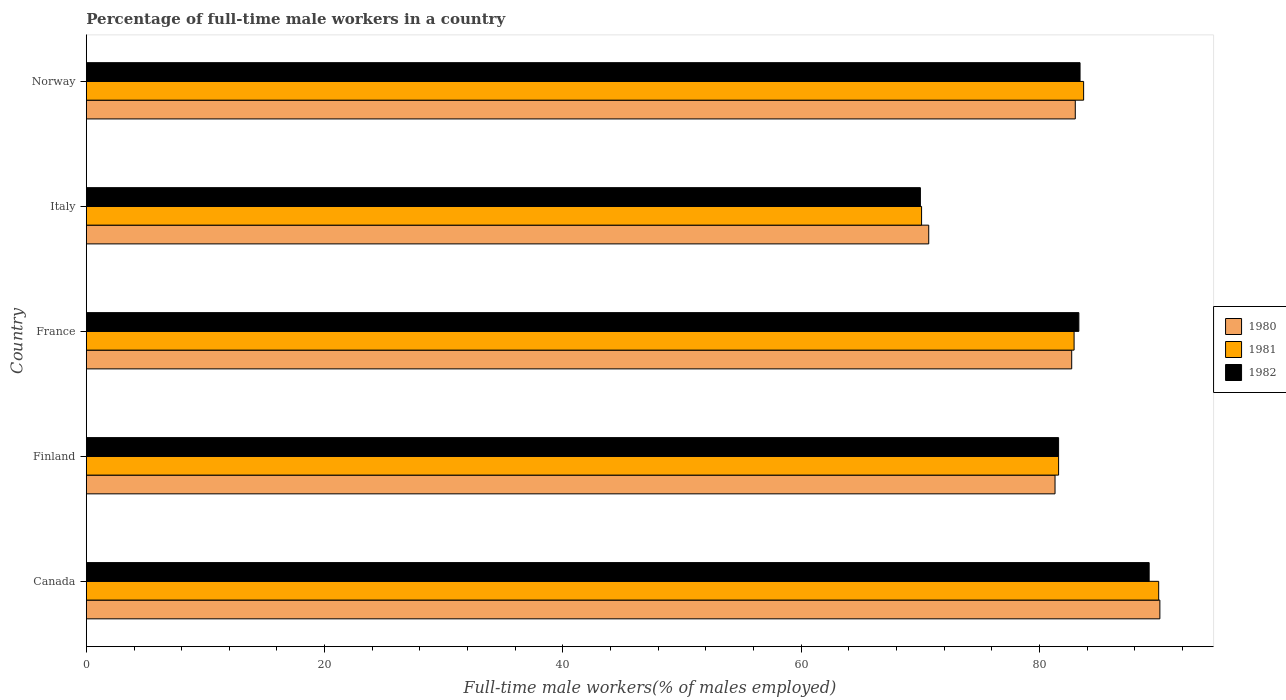How many different coloured bars are there?
Provide a succinct answer. 3. Are the number of bars per tick equal to the number of legend labels?
Provide a succinct answer. Yes. How many bars are there on the 4th tick from the top?
Give a very brief answer. 3. How many bars are there on the 4th tick from the bottom?
Give a very brief answer. 3. What is the label of the 1st group of bars from the top?
Your answer should be very brief. Norway. What is the percentage of full-time male workers in 1980 in Finland?
Provide a succinct answer. 81.3. Across all countries, what is the maximum percentage of full-time male workers in 1981?
Give a very brief answer. 90. What is the total percentage of full-time male workers in 1982 in the graph?
Your response must be concise. 407.5. What is the difference between the percentage of full-time male workers in 1982 in France and that in Norway?
Offer a very short reply. -0.1. What is the difference between the percentage of full-time male workers in 1982 in Canada and the percentage of full-time male workers in 1980 in Norway?
Your answer should be very brief. 6.2. What is the average percentage of full-time male workers in 1980 per country?
Your answer should be compact. 81.56. What is the difference between the percentage of full-time male workers in 1980 and percentage of full-time male workers in 1982 in Italy?
Keep it short and to the point. 0.7. In how many countries, is the percentage of full-time male workers in 1981 greater than 64 %?
Offer a terse response. 5. What is the ratio of the percentage of full-time male workers in 1981 in Canada to that in Finland?
Make the answer very short. 1.1. Is the percentage of full-time male workers in 1981 in Finland less than that in Norway?
Keep it short and to the point. Yes. Is the difference between the percentage of full-time male workers in 1980 in Canada and Norway greater than the difference between the percentage of full-time male workers in 1982 in Canada and Norway?
Make the answer very short. Yes. What is the difference between the highest and the second highest percentage of full-time male workers in 1982?
Offer a terse response. 5.8. What is the difference between the highest and the lowest percentage of full-time male workers in 1981?
Offer a terse response. 19.9. Is the sum of the percentage of full-time male workers in 1982 in Finland and Italy greater than the maximum percentage of full-time male workers in 1981 across all countries?
Ensure brevity in your answer.  Yes. Is it the case that in every country, the sum of the percentage of full-time male workers in 1981 and percentage of full-time male workers in 1982 is greater than the percentage of full-time male workers in 1980?
Keep it short and to the point. Yes. How many countries are there in the graph?
Offer a very short reply. 5. What is the difference between two consecutive major ticks on the X-axis?
Give a very brief answer. 20. Are the values on the major ticks of X-axis written in scientific E-notation?
Provide a succinct answer. No. Does the graph contain any zero values?
Provide a succinct answer. No. What is the title of the graph?
Ensure brevity in your answer.  Percentage of full-time male workers in a country. Does "2009" appear as one of the legend labels in the graph?
Make the answer very short. No. What is the label or title of the X-axis?
Your answer should be compact. Full-time male workers(% of males employed). What is the label or title of the Y-axis?
Provide a short and direct response. Country. What is the Full-time male workers(% of males employed) of 1980 in Canada?
Provide a short and direct response. 90.1. What is the Full-time male workers(% of males employed) in 1982 in Canada?
Provide a short and direct response. 89.2. What is the Full-time male workers(% of males employed) of 1980 in Finland?
Offer a terse response. 81.3. What is the Full-time male workers(% of males employed) of 1981 in Finland?
Give a very brief answer. 81.6. What is the Full-time male workers(% of males employed) of 1982 in Finland?
Provide a short and direct response. 81.6. What is the Full-time male workers(% of males employed) of 1980 in France?
Ensure brevity in your answer.  82.7. What is the Full-time male workers(% of males employed) of 1981 in France?
Offer a terse response. 82.9. What is the Full-time male workers(% of males employed) in 1982 in France?
Your response must be concise. 83.3. What is the Full-time male workers(% of males employed) of 1980 in Italy?
Make the answer very short. 70.7. What is the Full-time male workers(% of males employed) in 1981 in Italy?
Offer a terse response. 70.1. What is the Full-time male workers(% of males employed) in 1982 in Italy?
Make the answer very short. 70. What is the Full-time male workers(% of males employed) of 1980 in Norway?
Keep it short and to the point. 83. What is the Full-time male workers(% of males employed) in 1981 in Norway?
Offer a terse response. 83.7. What is the Full-time male workers(% of males employed) of 1982 in Norway?
Your answer should be very brief. 83.4. Across all countries, what is the maximum Full-time male workers(% of males employed) in 1980?
Offer a terse response. 90.1. Across all countries, what is the maximum Full-time male workers(% of males employed) of 1981?
Ensure brevity in your answer.  90. Across all countries, what is the maximum Full-time male workers(% of males employed) in 1982?
Provide a succinct answer. 89.2. Across all countries, what is the minimum Full-time male workers(% of males employed) of 1980?
Offer a terse response. 70.7. Across all countries, what is the minimum Full-time male workers(% of males employed) in 1981?
Provide a short and direct response. 70.1. What is the total Full-time male workers(% of males employed) in 1980 in the graph?
Offer a terse response. 407.8. What is the total Full-time male workers(% of males employed) in 1981 in the graph?
Your response must be concise. 408.3. What is the total Full-time male workers(% of males employed) in 1982 in the graph?
Your answer should be very brief. 407.5. What is the difference between the Full-time male workers(% of males employed) in 1981 in Canada and that in Finland?
Make the answer very short. 8.4. What is the difference between the Full-time male workers(% of males employed) in 1982 in Canada and that in Finland?
Your answer should be compact. 7.6. What is the difference between the Full-time male workers(% of males employed) in 1981 in Canada and that in France?
Provide a short and direct response. 7.1. What is the difference between the Full-time male workers(% of males employed) of 1980 in Canada and that in Italy?
Offer a terse response. 19.4. What is the difference between the Full-time male workers(% of males employed) in 1982 in Canada and that in Italy?
Offer a very short reply. 19.2. What is the difference between the Full-time male workers(% of males employed) of 1980 in Canada and that in Norway?
Offer a very short reply. 7.1. What is the difference between the Full-time male workers(% of males employed) of 1981 in Canada and that in Norway?
Offer a terse response. 6.3. What is the difference between the Full-time male workers(% of males employed) of 1981 in Finland and that in France?
Keep it short and to the point. -1.3. What is the difference between the Full-time male workers(% of males employed) of 1980 in Finland and that in Italy?
Your response must be concise. 10.6. What is the difference between the Full-time male workers(% of males employed) of 1981 in Finland and that in Italy?
Keep it short and to the point. 11.5. What is the difference between the Full-time male workers(% of males employed) in 1981 in Finland and that in Norway?
Your response must be concise. -2.1. What is the difference between the Full-time male workers(% of males employed) in 1981 in France and that in Norway?
Make the answer very short. -0.8. What is the difference between the Full-time male workers(% of males employed) in 1980 in Canada and the Full-time male workers(% of males employed) in 1982 in Finland?
Give a very brief answer. 8.5. What is the difference between the Full-time male workers(% of males employed) of 1981 in Canada and the Full-time male workers(% of males employed) of 1982 in Finland?
Your response must be concise. 8.4. What is the difference between the Full-time male workers(% of males employed) in 1980 in Canada and the Full-time male workers(% of males employed) in 1981 in France?
Provide a succinct answer. 7.2. What is the difference between the Full-time male workers(% of males employed) of 1980 in Canada and the Full-time male workers(% of males employed) of 1982 in France?
Give a very brief answer. 6.8. What is the difference between the Full-time male workers(% of males employed) in 1980 in Canada and the Full-time male workers(% of males employed) in 1982 in Italy?
Keep it short and to the point. 20.1. What is the difference between the Full-time male workers(% of males employed) of 1981 in Canada and the Full-time male workers(% of males employed) of 1982 in Italy?
Provide a short and direct response. 20. What is the difference between the Full-time male workers(% of males employed) of 1980 in Canada and the Full-time male workers(% of males employed) of 1981 in Norway?
Offer a terse response. 6.4. What is the difference between the Full-time male workers(% of males employed) of 1980 in Canada and the Full-time male workers(% of males employed) of 1982 in Norway?
Your answer should be very brief. 6.7. What is the difference between the Full-time male workers(% of males employed) of 1981 in Canada and the Full-time male workers(% of males employed) of 1982 in Norway?
Give a very brief answer. 6.6. What is the difference between the Full-time male workers(% of males employed) of 1980 in Finland and the Full-time male workers(% of males employed) of 1981 in France?
Your answer should be compact. -1.6. What is the difference between the Full-time male workers(% of males employed) in 1980 in Finland and the Full-time male workers(% of males employed) in 1982 in France?
Offer a terse response. -2. What is the difference between the Full-time male workers(% of males employed) in 1981 in Finland and the Full-time male workers(% of males employed) in 1982 in France?
Ensure brevity in your answer.  -1.7. What is the difference between the Full-time male workers(% of males employed) of 1981 in Finland and the Full-time male workers(% of males employed) of 1982 in Italy?
Give a very brief answer. 11.6. What is the difference between the Full-time male workers(% of males employed) of 1981 in Finland and the Full-time male workers(% of males employed) of 1982 in Norway?
Give a very brief answer. -1.8. What is the difference between the Full-time male workers(% of males employed) of 1980 in France and the Full-time male workers(% of males employed) of 1981 in Italy?
Your answer should be very brief. 12.6. What is the difference between the Full-time male workers(% of males employed) of 1981 in France and the Full-time male workers(% of males employed) of 1982 in Italy?
Your response must be concise. 12.9. What is the difference between the Full-time male workers(% of males employed) of 1980 in France and the Full-time male workers(% of males employed) of 1981 in Norway?
Your response must be concise. -1. What is the difference between the Full-time male workers(% of males employed) in 1980 in France and the Full-time male workers(% of males employed) in 1982 in Norway?
Offer a very short reply. -0.7. What is the difference between the Full-time male workers(% of males employed) of 1980 in Italy and the Full-time male workers(% of males employed) of 1982 in Norway?
Your response must be concise. -12.7. What is the average Full-time male workers(% of males employed) of 1980 per country?
Ensure brevity in your answer.  81.56. What is the average Full-time male workers(% of males employed) in 1981 per country?
Provide a succinct answer. 81.66. What is the average Full-time male workers(% of males employed) in 1982 per country?
Give a very brief answer. 81.5. What is the difference between the Full-time male workers(% of males employed) in 1980 and Full-time male workers(% of males employed) in 1981 in Canada?
Provide a short and direct response. 0.1. What is the difference between the Full-time male workers(% of males employed) of 1980 and Full-time male workers(% of males employed) of 1982 in Canada?
Your answer should be very brief. 0.9. What is the difference between the Full-time male workers(% of males employed) of 1980 and Full-time male workers(% of males employed) of 1981 in Finland?
Offer a very short reply. -0.3. What is the difference between the Full-time male workers(% of males employed) of 1980 and Full-time male workers(% of males employed) of 1982 in Finland?
Offer a terse response. -0.3. What is the difference between the Full-time male workers(% of males employed) in 1981 and Full-time male workers(% of males employed) in 1982 in Finland?
Keep it short and to the point. 0. What is the difference between the Full-time male workers(% of males employed) of 1981 and Full-time male workers(% of males employed) of 1982 in France?
Provide a short and direct response. -0.4. What is the difference between the Full-time male workers(% of males employed) in 1980 and Full-time male workers(% of males employed) in 1982 in Italy?
Your response must be concise. 0.7. What is the difference between the Full-time male workers(% of males employed) in 1980 and Full-time male workers(% of males employed) in 1981 in Norway?
Offer a terse response. -0.7. What is the difference between the Full-time male workers(% of males employed) of 1980 and Full-time male workers(% of males employed) of 1982 in Norway?
Offer a terse response. -0.4. What is the ratio of the Full-time male workers(% of males employed) in 1980 in Canada to that in Finland?
Provide a short and direct response. 1.11. What is the ratio of the Full-time male workers(% of males employed) in 1981 in Canada to that in Finland?
Ensure brevity in your answer.  1.1. What is the ratio of the Full-time male workers(% of males employed) in 1982 in Canada to that in Finland?
Your response must be concise. 1.09. What is the ratio of the Full-time male workers(% of males employed) of 1980 in Canada to that in France?
Provide a succinct answer. 1.09. What is the ratio of the Full-time male workers(% of males employed) of 1981 in Canada to that in France?
Make the answer very short. 1.09. What is the ratio of the Full-time male workers(% of males employed) in 1982 in Canada to that in France?
Offer a very short reply. 1.07. What is the ratio of the Full-time male workers(% of males employed) of 1980 in Canada to that in Italy?
Offer a very short reply. 1.27. What is the ratio of the Full-time male workers(% of males employed) in 1981 in Canada to that in Italy?
Make the answer very short. 1.28. What is the ratio of the Full-time male workers(% of males employed) in 1982 in Canada to that in Italy?
Offer a very short reply. 1.27. What is the ratio of the Full-time male workers(% of males employed) in 1980 in Canada to that in Norway?
Your answer should be very brief. 1.09. What is the ratio of the Full-time male workers(% of males employed) in 1981 in Canada to that in Norway?
Your response must be concise. 1.08. What is the ratio of the Full-time male workers(% of males employed) of 1982 in Canada to that in Norway?
Provide a succinct answer. 1.07. What is the ratio of the Full-time male workers(% of males employed) of 1980 in Finland to that in France?
Provide a succinct answer. 0.98. What is the ratio of the Full-time male workers(% of males employed) in 1981 in Finland to that in France?
Ensure brevity in your answer.  0.98. What is the ratio of the Full-time male workers(% of males employed) of 1982 in Finland to that in France?
Provide a succinct answer. 0.98. What is the ratio of the Full-time male workers(% of males employed) in 1980 in Finland to that in Italy?
Make the answer very short. 1.15. What is the ratio of the Full-time male workers(% of males employed) in 1981 in Finland to that in Italy?
Your answer should be very brief. 1.16. What is the ratio of the Full-time male workers(% of males employed) in 1982 in Finland to that in Italy?
Your answer should be very brief. 1.17. What is the ratio of the Full-time male workers(% of males employed) of 1980 in Finland to that in Norway?
Make the answer very short. 0.98. What is the ratio of the Full-time male workers(% of males employed) in 1981 in Finland to that in Norway?
Provide a short and direct response. 0.97. What is the ratio of the Full-time male workers(% of males employed) in 1982 in Finland to that in Norway?
Offer a terse response. 0.98. What is the ratio of the Full-time male workers(% of males employed) of 1980 in France to that in Italy?
Make the answer very short. 1.17. What is the ratio of the Full-time male workers(% of males employed) of 1981 in France to that in Italy?
Give a very brief answer. 1.18. What is the ratio of the Full-time male workers(% of males employed) of 1982 in France to that in Italy?
Offer a very short reply. 1.19. What is the ratio of the Full-time male workers(% of males employed) of 1981 in France to that in Norway?
Give a very brief answer. 0.99. What is the ratio of the Full-time male workers(% of males employed) of 1980 in Italy to that in Norway?
Your answer should be very brief. 0.85. What is the ratio of the Full-time male workers(% of males employed) in 1981 in Italy to that in Norway?
Keep it short and to the point. 0.84. What is the ratio of the Full-time male workers(% of males employed) in 1982 in Italy to that in Norway?
Your answer should be very brief. 0.84. What is the difference between the highest and the second highest Full-time male workers(% of males employed) of 1981?
Give a very brief answer. 6.3. What is the difference between the highest and the second highest Full-time male workers(% of males employed) of 1982?
Offer a terse response. 5.8. What is the difference between the highest and the lowest Full-time male workers(% of males employed) in 1980?
Your answer should be compact. 19.4. What is the difference between the highest and the lowest Full-time male workers(% of males employed) of 1981?
Keep it short and to the point. 19.9. What is the difference between the highest and the lowest Full-time male workers(% of males employed) of 1982?
Offer a terse response. 19.2. 